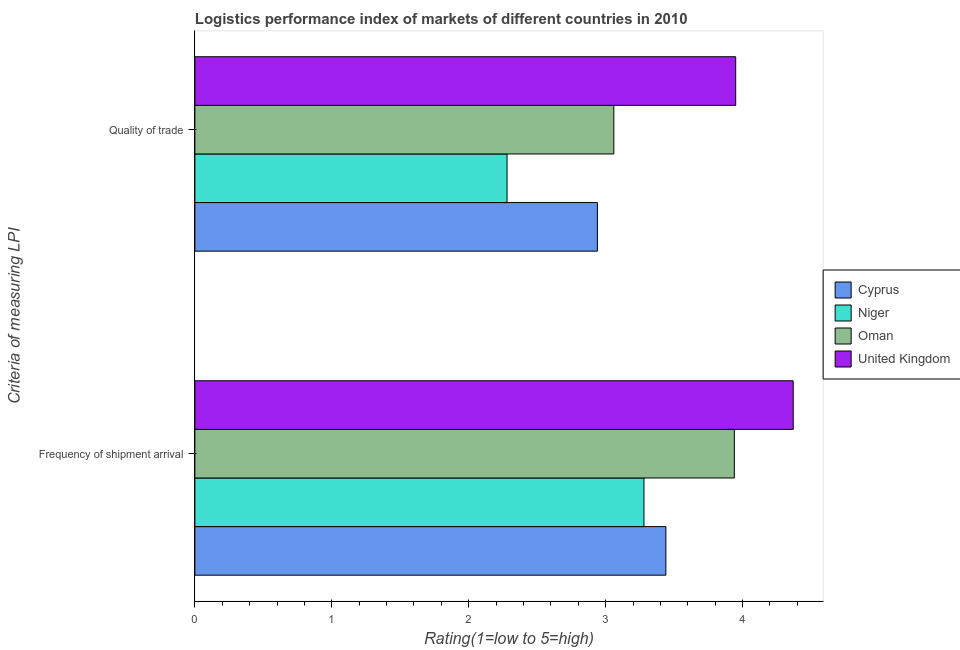How many different coloured bars are there?
Make the answer very short. 4. How many groups of bars are there?
Your answer should be compact. 2. How many bars are there on the 1st tick from the bottom?
Your answer should be compact. 4. What is the label of the 1st group of bars from the top?
Provide a short and direct response. Quality of trade. What is the lpi quality of trade in United Kingdom?
Provide a succinct answer. 3.95. Across all countries, what is the maximum lpi of frequency of shipment arrival?
Make the answer very short. 4.37. Across all countries, what is the minimum lpi of frequency of shipment arrival?
Ensure brevity in your answer.  3.28. In which country was the lpi of frequency of shipment arrival minimum?
Ensure brevity in your answer.  Niger. What is the total lpi quality of trade in the graph?
Offer a terse response. 12.23. What is the difference between the lpi quality of trade in United Kingdom and that in Cyprus?
Your answer should be compact. 1.01. What is the difference between the lpi of frequency of shipment arrival in Niger and the lpi quality of trade in United Kingdom?
Provide a short and direct response. -0.67. What is the average lpi of frequency of shipment arrival per country?
Provide a short and direct response. 3.76. In how many countries, is the lpi of frequency of shipment arrival greater than 0.8 ?
Ensure brevity in your answer.  4. What is the ratio of the lpi of frequency of shipment arrival in Oman to that in United Kingdom?
Ensure brevity in your answer.  0.9. What does the 2nd bar from the top in Quality of trade represents?
Offer a terse response. Oman. Are all the bars in the graph horizontal?
Your answer should be very brief. Yes. What is the difference between two consecutive major ticks on the X-axis?
Provide a succinct answer. 1. How are the legend labels stacked?
Provide a succinct answer. Vertical. What is the title of the graph?
Provide a short and direct response. Logistics performance index of markets of different countries in 2010. Does "European Union" appear as one of the legend labels in the graph?
Provide a succinct answer. No. What is the label or title of the X-axis?
Offer a very short reply. Rating(1=low to 5=high). What is the label or title of the Y-axis?
Provide a succinct answer. Criteria of measuring LPI. What is the Rating(1=low to 5=high) of Cyprus in Frequency of shipment arrival?
Provide a succinct answer. 3.44. What is the Rating(1=low to 5=high) of Niger in Frequency of shipment arrival?
Offer a terse response. 3.28. What is the Rating(1=low to 5=high) in Oman in Frequency of shipment arrival?
Your response must be concise. 3.94. What is the Rating(1=low to 5=high) of United Kingdom in Frequency of shipment arrival?
Provide a short and direct response. 4.37. What is the Rating(1=low to 5=high) of Cyprus in Quality of trade?
Your answer should be compact. 2.94. What is the Rating(1=low to 5=high) of Niger in Quality of trade?
Give a very brief answer. 2.28. What is the Rating(1=low to 5=high) of Oman in Quality of trade?
Ensure brevity in your answer.  3.06. What is the Rating(1=low to 5=high) of United Kingdom in Quality of trade?
Your response must be concise. 3.95. Across all Criteria of measuring LPI, what is the maximum Rating(1=low to 5=high) of Cyprus?
Your answer should be very brief. 3.44. Across all Criteria of measuring LPI, what is the maximum Rating(1=low to 5=high) of Niger?
Your answer should be very brief. 3.28. Across all Criteria of measuring LPI, what is the maximum Rating(1=low to 5=high) of Oman?
Offer a terse response. 3.94. Across all Criteria of measuring LPI, what is the maximum Rating(1=low to 5=high) in United Kingdom?
Your answer should be very brief. 4.37. Across all Criteria of measuring LPI, what is the minimum Rating(1=low to 5=high) in Cyprus?
Keep it short and to the point. 2.94. Across all Criteria of measuring LPI, what is the minimum Rating(1=low to 5=high) of Niger?
Your answer should be very brief. 2.28. Across all Criteria of measuring LPI, what is the minimum Rating(1=low to 5=high) of Oman?
Your answer should be compact. 3.06. Across all Criteria of measuring LPI, what is the minimum Rating(1=low to 5=high) in United Kingdom?
Offer a terse response. 3.95. What is the total Rating(1=low to 5=high) of Cyprus in the graph?
Your answer should be compact. 6.38. What is the total Rating(1=low to 5=high) of Niger in the graph?
Offer a terse response. 5.56. What is the total Rating(1=low to 5=high) in Oman in the graph?
Your answer should be compact. 7. What is the total Rating(1=low to 5=high) of United Kingdom in the graph?
Your answer should be compact. 8.32. What is the difference between the Rating(1=low to 5=high) in Cyprus in Frequency of shipment arrival and that in Quality of trade?
Your answer should be compact. 0.5. What is the difference between the Rating(1=low to 5=high) of Oman in Frequency of shipment arrival and that in Quality of trade?
Provide a short and direct response. 0.88. What is the difference between the Rating(1=low to 5=high) in United Kingdom in Frequency of shipment arrival and that in Quality of trade?
Provide a short and direct response. 0.42. What is the difference between the Rating(1=low to 5=high) in Cyprus in Frequency of shipment arrival and the Rating(1=low to 5=high) in Niger in Quality of trade?
Provide a succinct answer. 1.16. What is the difference between the Rating(1=low to 5=high) in Cyprus in Frequency of shipment arrival and the Rating(1=low to 5=high) in Oman in Quality of trade?
Your response must be concise. 0.38. What is the difference between the Rating(1=low to 5=high) in Cyprus in Frequency of shipment arrival and the Rating(1=low to 5=high) in United Kingdom in Quality of trade?
Ensure brevity in your answer.  -0.51. What is the difference between the Rating(1=low to 5=high) in Niger in Frequency of shipment arrival and the Rating(1=low to 5=high) in Oman in Quality of trade?
Provide a short and direct response. 0.22. What is the difference between the Rating(1=low to 5=high) in Niger in Frequency of shipment arrival and the Rating(1=low to 5=high) in United Kingdom in Quality of trade?
Provide a succinct answer. -0.67. What is the difference between the Rating(1=low to 5=high) in Oman in Frequency of shipment arrival and the Rating(1=low to 5=high) in United Kingdom in Quality of trade?
Your answer should be very brief. -0.01. What is the average Rating(1=low to 5=high) of Cyprus per Criteria of measuring LPI?
Your answer should be very brief. 3.19. What is the average Rating(1=low to 5=high) of Niger per Criteria of measuring LPI?
Provide a succinct answer. 2.78. What is the average Rating(1=low to 5=high) in Oman per Criteria of measuring LPI?
Provide a short and direct response. 3.5. What is the average Rating(1=low to 5=high) of United Kingdom per Criteria of measuring LPI?
Make the answer very short. 4.16. What is the difference between the Rating(1=low to 5=high) of Cyprus and Rating(1=low to 5=high) of Niger in Frequency of shipment arrival?
Your response must be concise. 0.16. What is the difference between the Rating(1=low to 5=high) in Cyprus and Rating(1=low to 5=high) in United Kingdom in Frequency of shipment arrival?
Give a very brief answer. -0.93. What is the difference between the Rating(1=low to 5=high) of Niger and Rating(1=low to 5=high) of Oman in Frequency of shipment arrival?
Your answer should be very brief. -0.66. What is the difference between the Rating(1=low to 5=high) in Niger and Rating(1=low to 5=high) in United Kingdom in Frequency of shipment arrival?
Ensure brevity in your answer.  -1.09. What is the difference between the Rating(1=low to 5=high) of Oman and Rating(1=low to 5=high) of United Kingdom in Frequency of shipment arrival?
Offer a terse response. -0.43. What is the difference between the Rating(1=low to 5=high) in Cyprus and Rating(1=low to 5=high) in Niger in Quality of trade?
Keep it short and to the point. 0.66. What is the difference between the Rating(1=low to 5=high) in Cyprus and Rating(1=low to 5=high) in Oman in Quality of trade?
Keep it short and to the point. -0.12. What is the difference between the Rating(1=low to 5=high) of Cyprus and Rating(1=low to 5=high) of United Kingdom in Quality of trade?
Your answer should be compact. -1.01. What is the difference between the Rating(1=low to 5=high) in Niger and Rating(1=low to 5=high) in Oman in Quality of trade?
Offer a very short reply. -0.78. What is the difference between the Rating(1=low to 5=high) of Niger and Rating(1=low to 5=high) of United Kingdom in Quality of trade?
Keep it short and to the point. -1.67. What is the difference between the Rating(1=low to 5=high) in Oman and Rating(1=low to 5=high) in United Kingdom in Quality of trade?
Provide a short and direct response. -0.89. What is the ratio of the Rating(1=low to 5=high) of Cyprus in Frequency of shipment arrival to that in Quality of trade?
Your answer should be very brief. 1.17. What is the ratio of the Rating(1=low to 5=high) in Niger in Frequency of shipment arrival to that in Quality of trade?
Offer a very short reply. 1.44. What is the ratio of the Rating(1=low to 5=high) of Oman in Frequency of shipment arrival to that in Quality of trade?
Ensure brevity in your answer.  1.29. What is the ratio of the Rating(1=low to 5=high) in United Kingdom in Frequency of shipment arrival to that in Quality of trade?
Your response must be concise. 1.11. What is the difference between the highest and the second highest Rating(1=low to 5=high) of Cyprus?
Provide a short and direct response. 0.5. What is the difference between the highest and the second highest Rating(1=low to 5=high) of Niger?
Keep it short and to the point. 1. What is the difference between the highest and the second highest Rating(1=low to 5=high) of United Kingdom?
Offer a very short reply. 0.42. What is the difference between the highest and the lowest Rating(1=low to 5=high) of Niger?
Provide a short and direct response. 1. What is the difference between the highest and the lowest Rating(1=low to 5=high) in Oman?
Provide a short and direct response. 0.88. What is the difference between the highest and the lowest Rating(1=low to 5=high) of United Kingdom?
Keep it short and to the point. 0.42. 